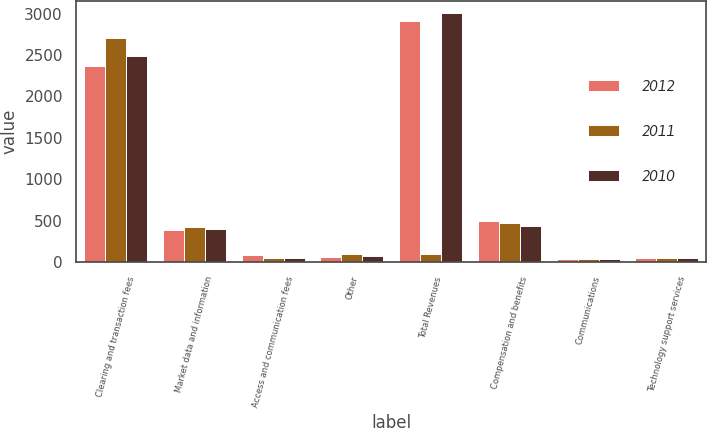Convert chart. <chart><loc_0><loc_0><loc_500><loc_500><stacked_bar_chart><ecel><fcel>Clearing and transaction fees<fcel>Market data and information<fcel>Access and communication fees<fcel>Other<fcel>Total Revenues<fcel>Compensation and benefits<fcel>Communications<fcel>Technology support services<nl><fcel>2012<fcel>2371.5<fcel>387.1<fcel>88.8<fcel>67.2<fcel>2914.6<fcel>496.7<fcel>40.1<fcel>50.7<nl><fcel>2011<fcel>2710.9<fcel>427.7<fcel>49.2<fcel>92.8<fcel>92.8<fcel>475.7<fcel>42.3<fcel>52.1<nl><fcel>2010<fcel>2486.3<fcel>395.1<fcel>45.4<fcel>76.9<fcel>3003.7<fcel>432.1<fcel>40.6<fcel>50.5<nl></chart> 